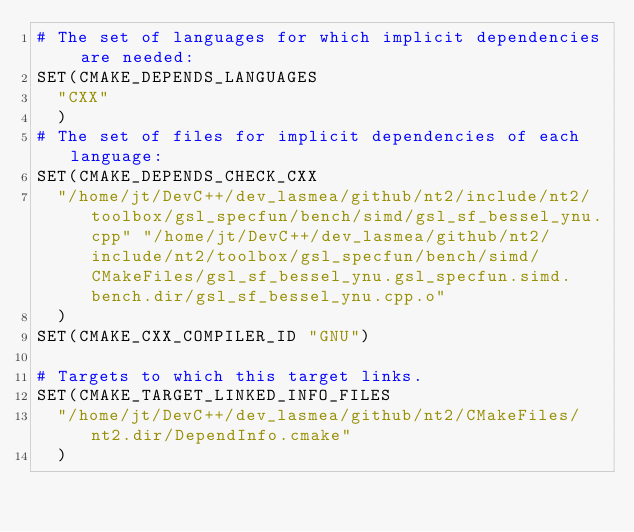Convert code to text. <code><loc_0><loc_0><loc_500><loc_500><_CMake_># The set of languages for which implicit dependencies are needed:
SET(CMAKE_DEPENDS_LANGUAGES
  "CXX"
  )
# The set of files for implicit dependencies of each language:
SET(CMAKE_DEPENDS_CHECK_CXX
  "/home/jt/DevC++/dev_lasmea/github/nt2/include/nt2/toolbox/gsl_specfun/bench/simd/gsl_sf_bessel_ynu.cpp" "/home/jt/DevC++/dev_lasmea/github/nt2/include/nt2/toolbox/gsl_specfun/bench/simd/CMakeFiles/gsl_sf_bessel_ynu.gsl_specfun.simd.bench.dir/gsl_sf_bessel_ynu.cpp.o"
  )
SET(CMAKE_CXX_COMPILER_ID "GNU")

# Targets to which this target links.
SET(CMAKE_TARGET_LINKED_INFO_FILES
  "/home/jt/DevC++/dev_lasmea/github/nt2/CMakeFiles/nt2.dir/DependInfo.cmake"
  )
</code> 